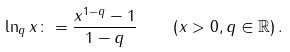<formula> <loc_0><loc_0><loc_500><loc_500>\ln _ { q } x \colon = \frac { x ^ { 1 - q } - 1 } { 1 - q } \quad \left ( x > 0 , q \in \mathbb { R } \right ) .</formula> 